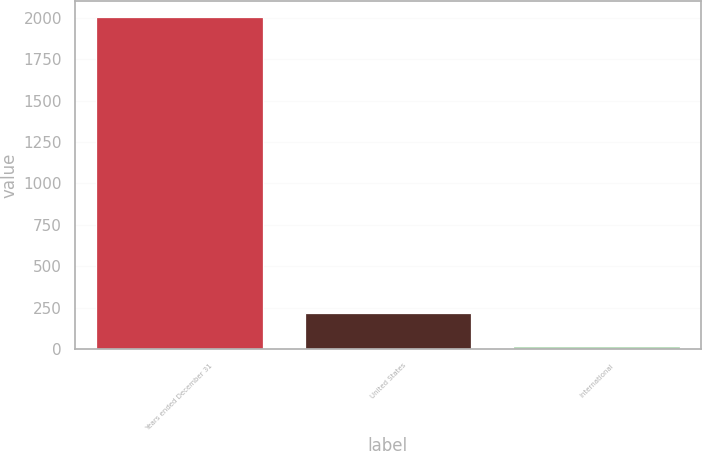Convert chart to OTSL. <chart><loc_0><loc_0><loc_500><loc_500><bar_chart><fcel>Years ended December 31<fcel>United States<fcel>International<nl><fcel>2003<fcel>217.4<fcel>19<nl></chart> 